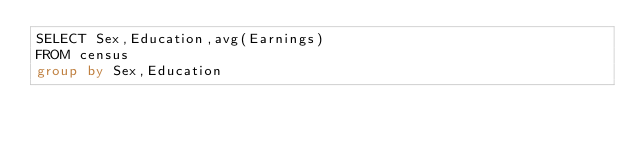<code> <loc_0><loc_0><loc_500><loc_500><_SQL_>SELECT Sex,Education,avg(Earnings)
FROM census
group by Sex,Education</code> 